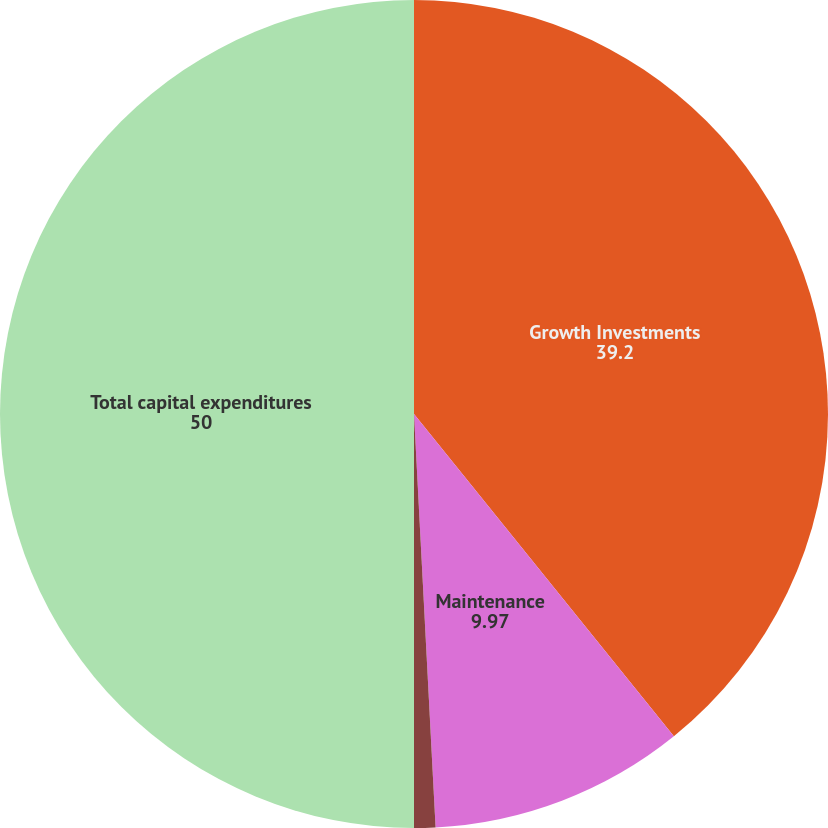<chart> <loc_0><loc_0><loc_500><loc_500><pie_chart><fcel>Growth Investments<fcel>Maintenance<fcel>Environmental<fcel>Total capital expenditures<nl><fcel>39.2%<fcel>9.97%<fcel>0.83%<fcel>50.0%<nl></chart> 